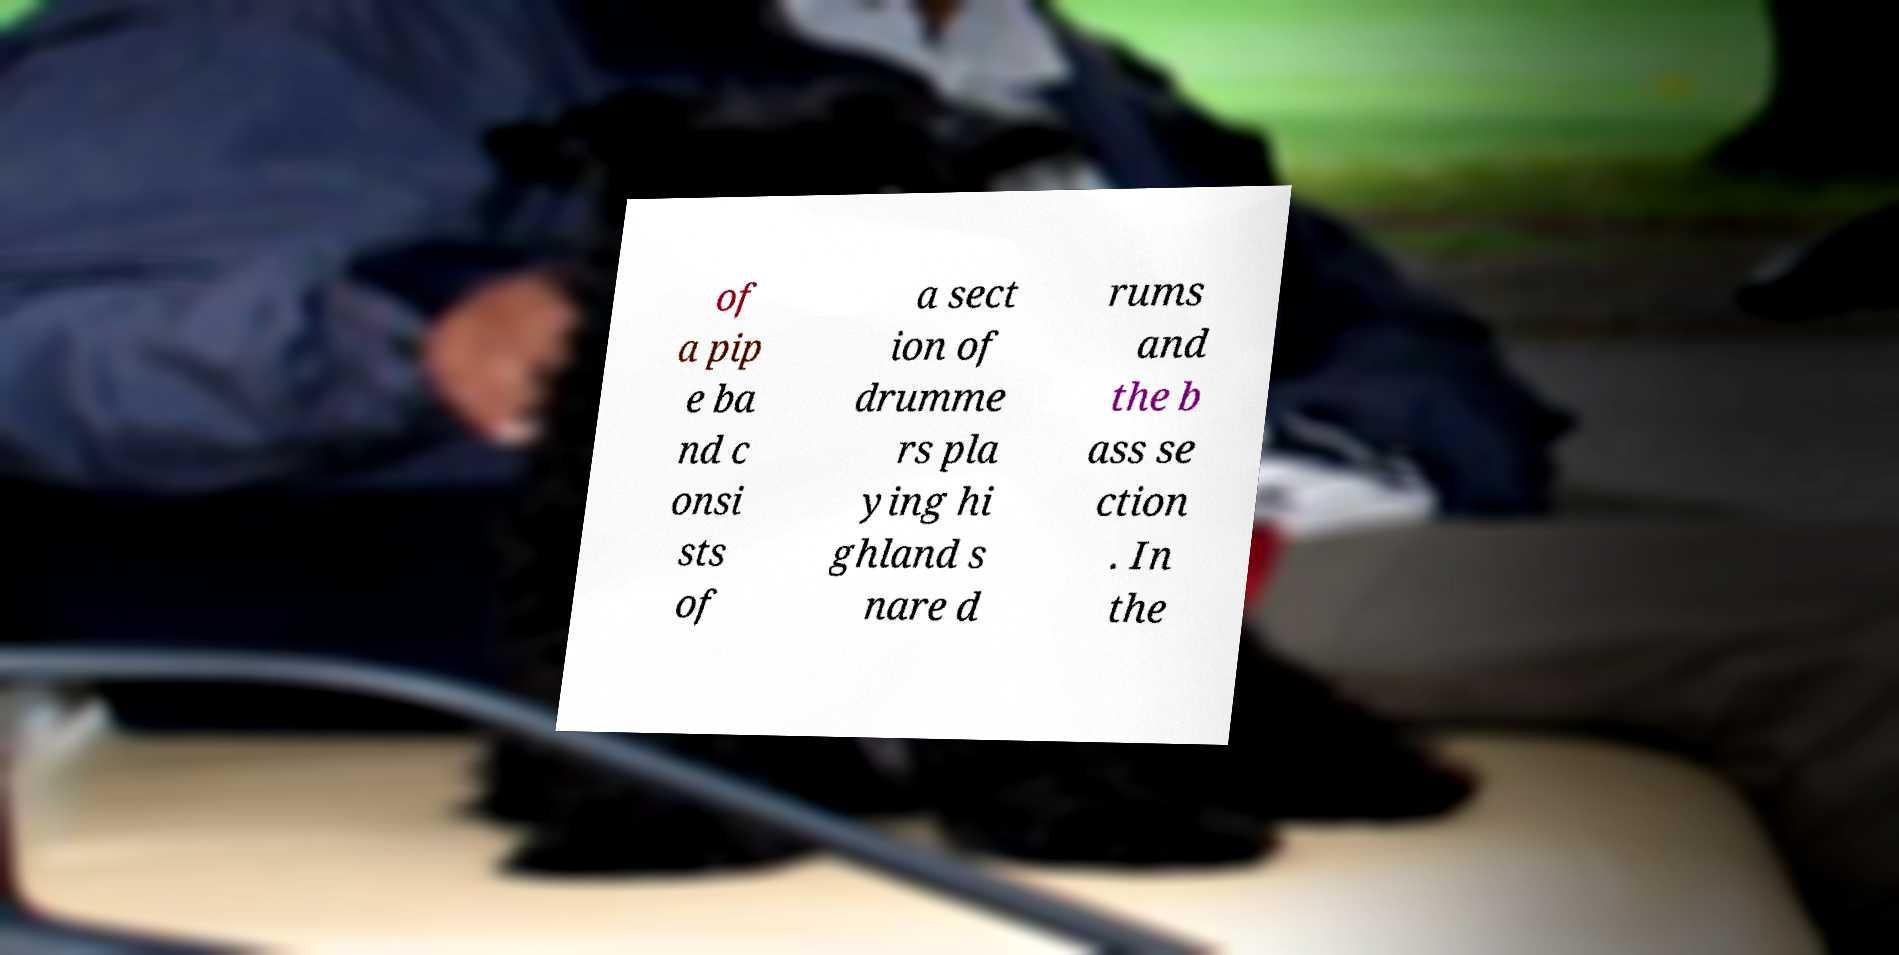Please identify and transcribe the text found in this image. of a pip e ba nd c onsi sts of a sect ion of drumme rs pla ying hi ghland s nare d rums and the b ass se ction . In the 